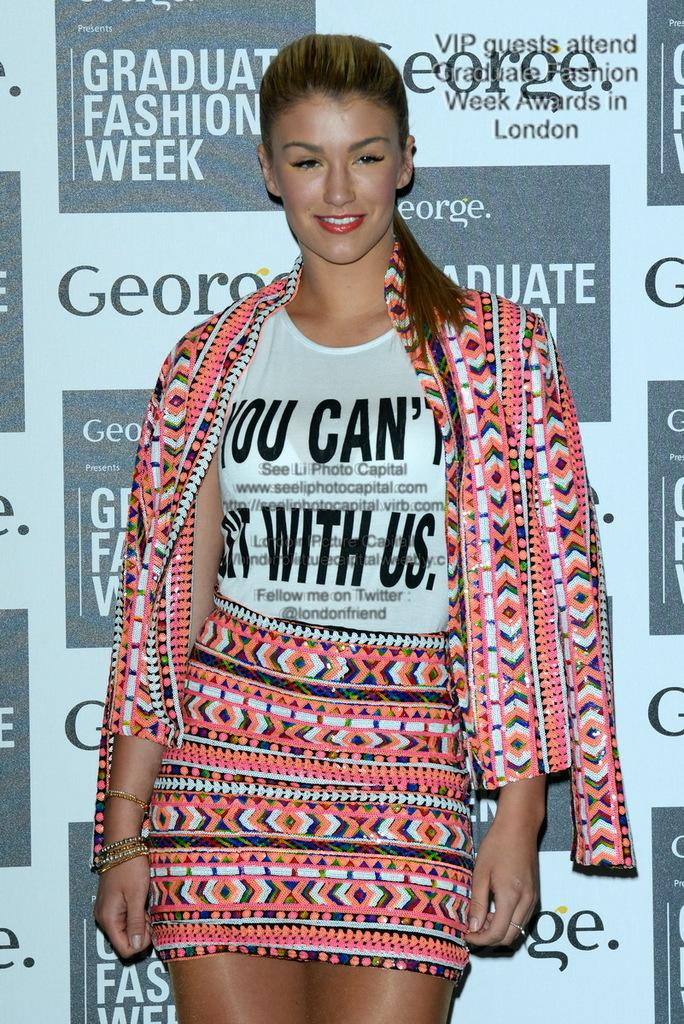What is the main subject of the image? There is a woman standing in the image. Can you describe the background of the image? There is a hoarding in the background of the image. What type of education is the robin receiving in the image? There is no robin present in the image, and therefore no education can be observed. 